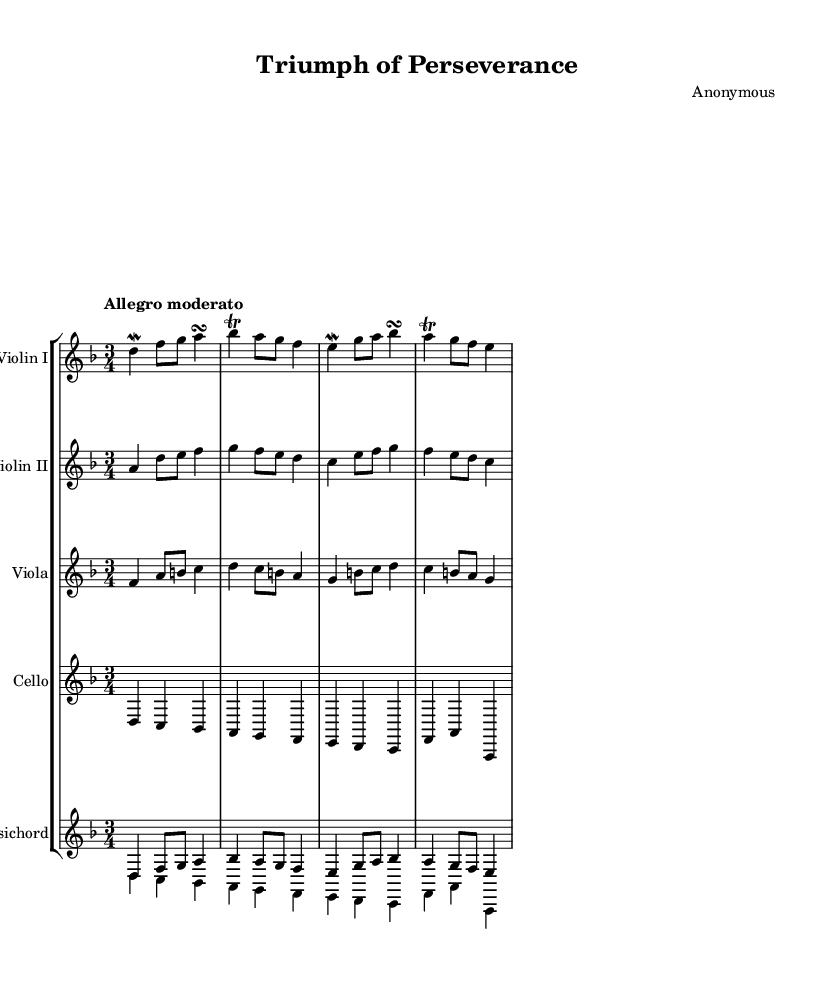what is the key signature of this music? The key signature is D minor, which has one flat indicated by the presence of the B flat in the music.
Answer: D minor what is the time signature of this piece? The time signature is indicated at the beginning of the music with the fraction showing three beats per measure, which is represented as 3/4.
Answer: 3/4 what is the tempo marking for this music? The tempo marking states "Allegro moderato," which indicates a moderate and lively pace for the piece.
Answer: Allegro moderato how many measures are there in the violin I part? Counting the measures from the sheet music, there are a total of four measures present in the violin I part.
Answer: 4 which instruments are featured in this score? The score includes Violin I, Violin II, Viola, Cello, and Harpsichord, as indicated by the labels at the beginning of each staff.
Answer: Violin I, Violin II, Viola, Cello, Harpsichord what form does this piece suggest considering its structure? The piece appears to follow a binary form, as evidenced by the division of the music into distinguishable sections and similar melodies revisited.
Answer: Binary form how does the use of ornaments relate to the Baroque style in this piece? The presence of mordents, trills, and turns in the melody is characteristic of the Baroque style, often used to embellish notes and enhance expressiveness.
Answer: Ornamentation 